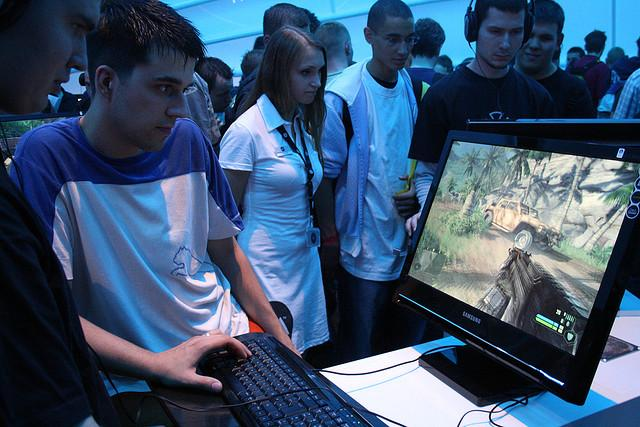What are the two men watching? video game 